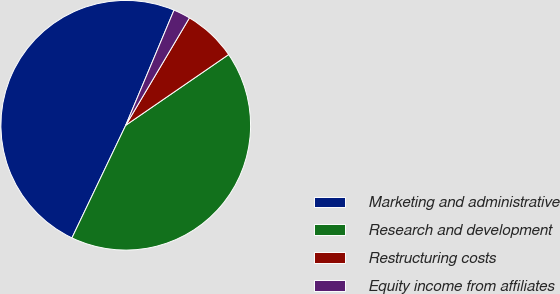<chart> <loc_0><loc_0><loc_500><loc_500><pie_chart><fcel>Marketing and administrative<fcel>Research and development<fcel>Restructuring costs<fcel>Equity income from affiliates<nl><fcel>49.22%<fcel>41.67%<fcel>6.9%<fcel>2.2%<nl></chart> 